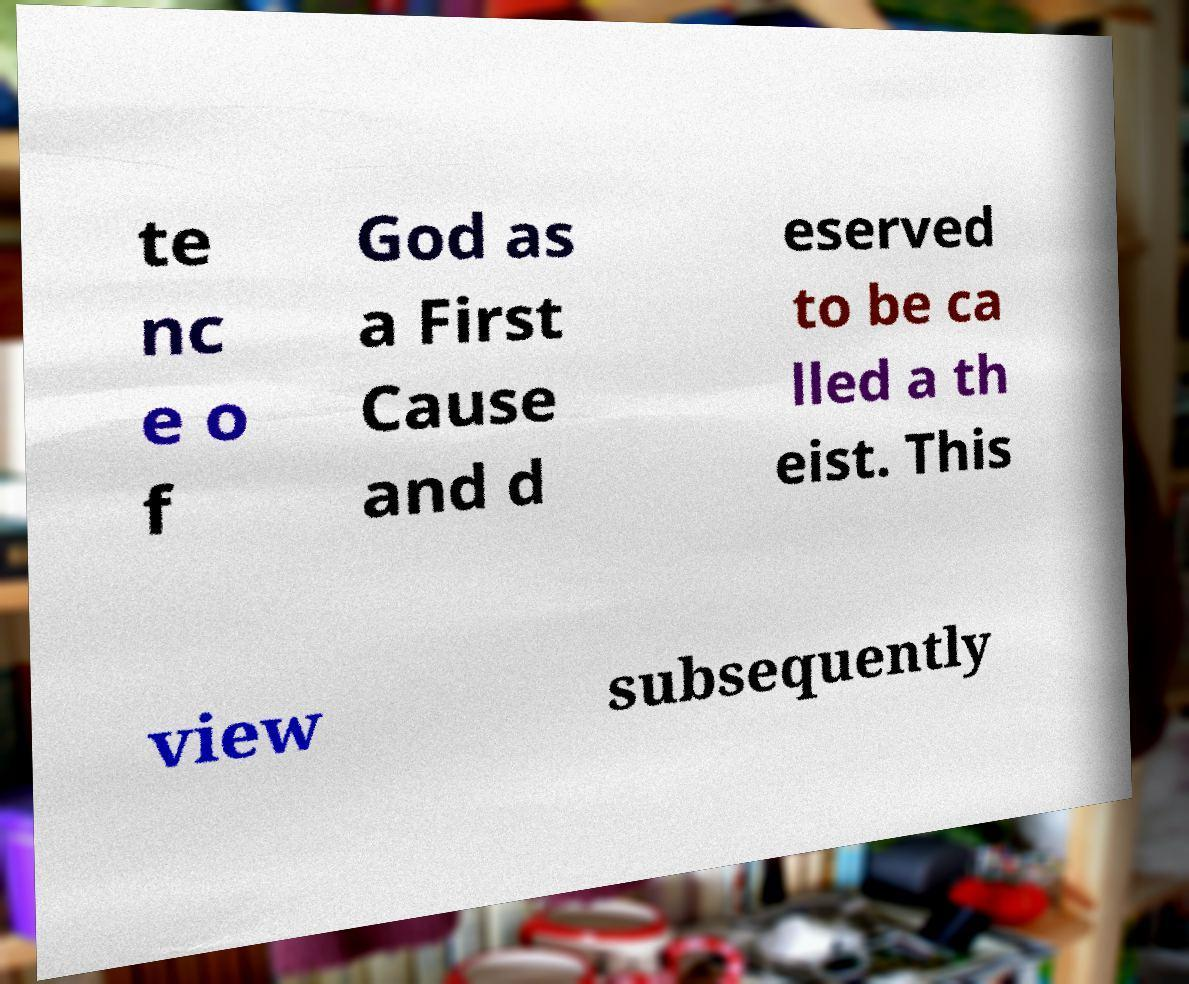Please identify and transcribe the text found in this image. te nc e o f God as a First Cause and d eserved to be ca lled a th eist. This view subsequently 